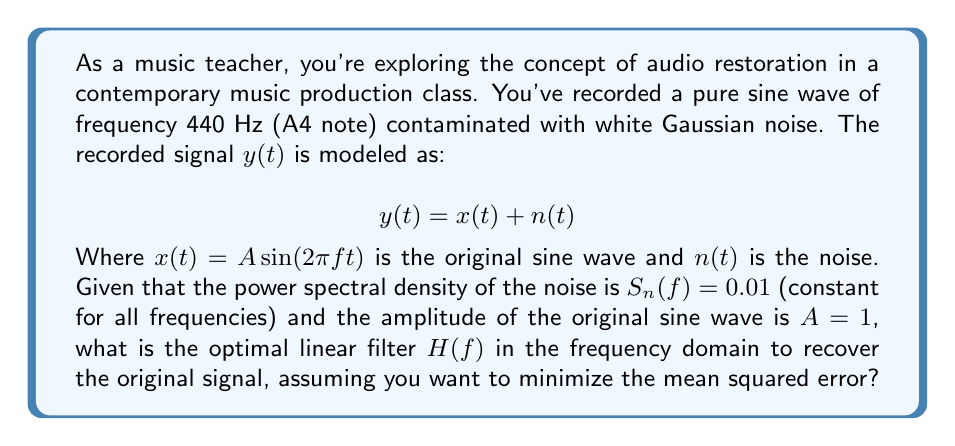Can you solve this math problem? To solve this inverse problem and recover the original signal, we'll use the Wiener filter, which is optimal for minimizing the mean squared error in the presence of additive noise.

Step 1: Identify the components
- Original signal: $x(t) = A \sin(2\pi f t)$, where $A = 1$ and $f = 440$ Hz
- Noise: $n(t)$ with power spectral density $S_n(f) = 0.01$

Step 2: Calculate the power spectral density of the original signal
For a sine wave, the power spectral density is a delta function:
$$S_x(f) = \frac{A^2}{4}[\delta(f-f_0) + \delta(f+f_0)]$$
Where $f_0 = 440$ Hz and $A = 1$, so:
$$S_x(f) = \frac{1}{4}[\delta(f-440) + \delta(f+440)]$$

Step 3: Apply the Wiener filter formula
The Wiener filter in the frequency domain is given by:
$$H(f) = \frac{S_x(f)}{S_x(f) + S_n(f)}$$

Step 4: Substitute the values
$$H(f) = \frac{\frac{1}{4}[\delta(f-440) + \delta(f+440)]}{\frac{1}{4}[\delta(f-440) + \delta(f+440)] + 0.01}$$

Step 5: Simplify
At $f = \pm 440$ Hz:
$$H(\pm 440) = \frac{0.25}{0.25 + 0.01} = \frac{25}{26} \approx 0.9615$$

At all other frequencies:
$$H(f) = \frac{0}{0 + 0.01} = 0$$

Therefore, the optimal Wiener filter is a narrow bandpass filter centered at 440 Hz with a gain of approximately 0.9615.
Answer: $H(f) = \begin{cases} 
0.9615, & \text{if } f = \pm 440 \text{ Hz} \\
0, & \text{otherwise}
\end{cases}$ 